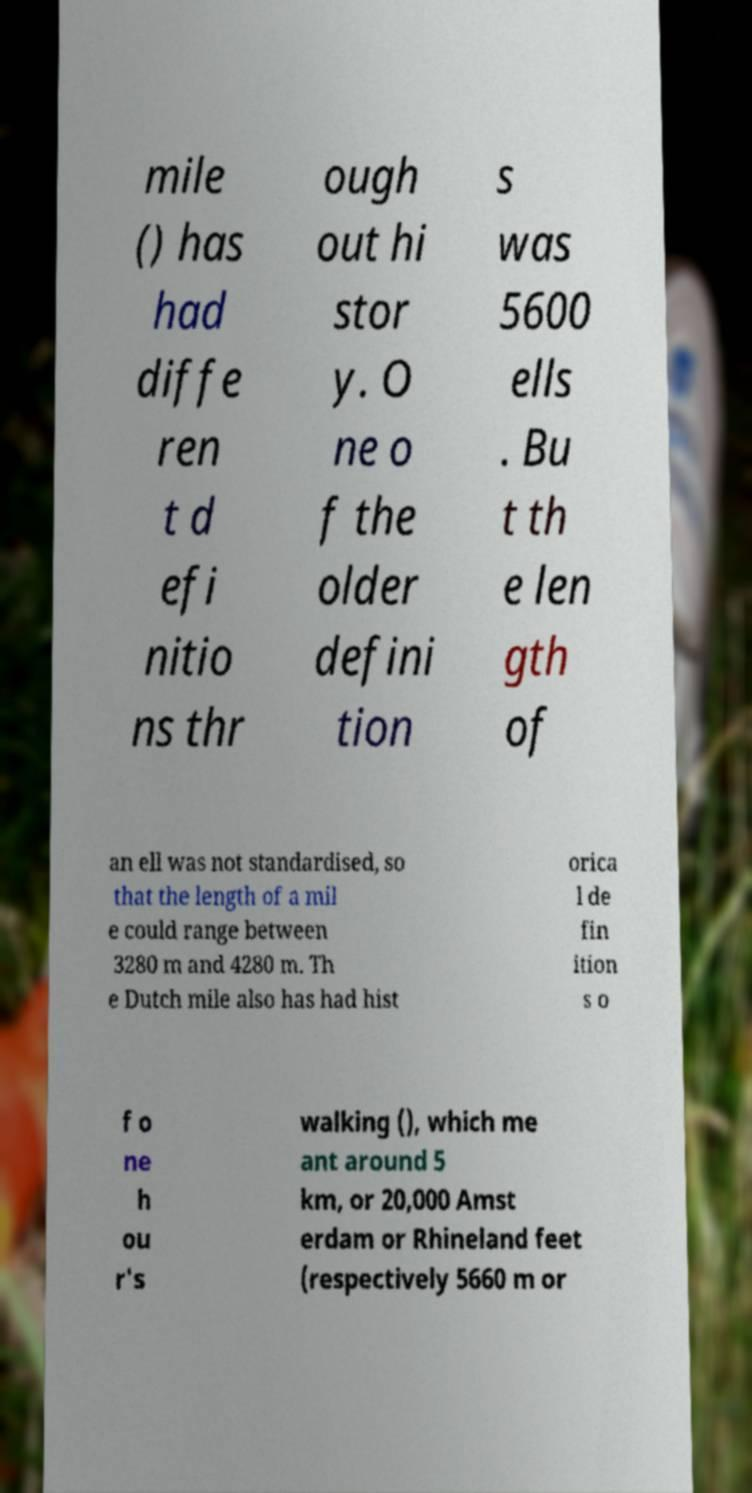Could you extract and type out the text from this image? mile () has had diffe ren t d efi nitio ns thr ough out hi stor y. O ne o f the older defini tion s was 5600 ells . Bu t th e len gth of an ell was not standardised, so that the length of a mil e could range between 3280 m and 4280 m. Th e Dutch mile also has had hist orica l de fin ition s o f o ne h ou r's walking (), which me ant around 5 km, or 20,000 Amst erdam or Rhineland feet (respectively 5660 m or 